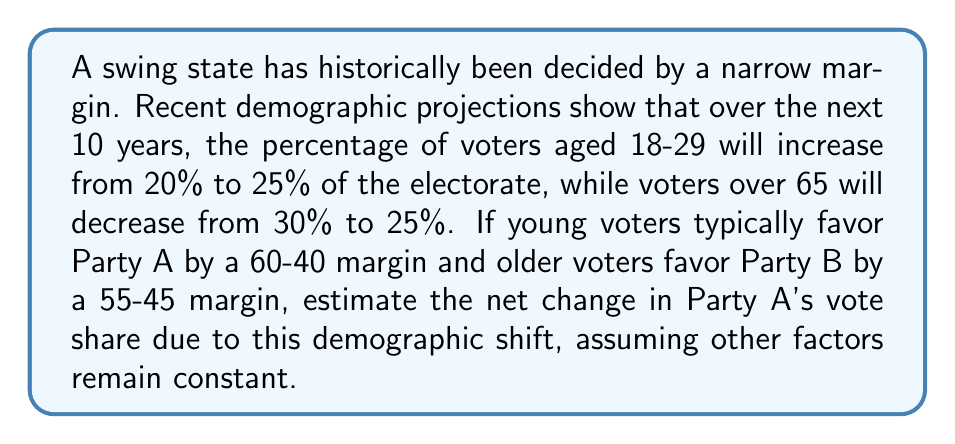Provide a solution to this math problem. Let's approach this step-by-step:

1) First, we need to calculate the current vote share for Party A from these two age groups:

   Young voters (20% of electorate):
   $20\% \times 60\% = 12\%$ for Party A

   Older voters (30% of electorate):
   $30\% \times 45\% = 13.5\%$ for Party A

   Total current share: $12\% + 13.5\% = 25.5\%$

2) Now, let's calculate the future vote share for Party A:

   Young voters (25% of electorate):
   $25\% \times 60\% = 15\%$ for Party A

   Older voters (25% of electorate):
   $25\% \times 45\% = 11.25\%$ for Party A

   Total future share: $15\% + 11.25\% = 26.25\%$

3) To find the net change, we subtract the current share from the future share:

   $26.25\% - 25.5\% = 0.75\%$

Therefore, the demographic shift is estimated to increase Party A's vote share by 0.75 percentage points.
Answer: 0.75 percentage points 